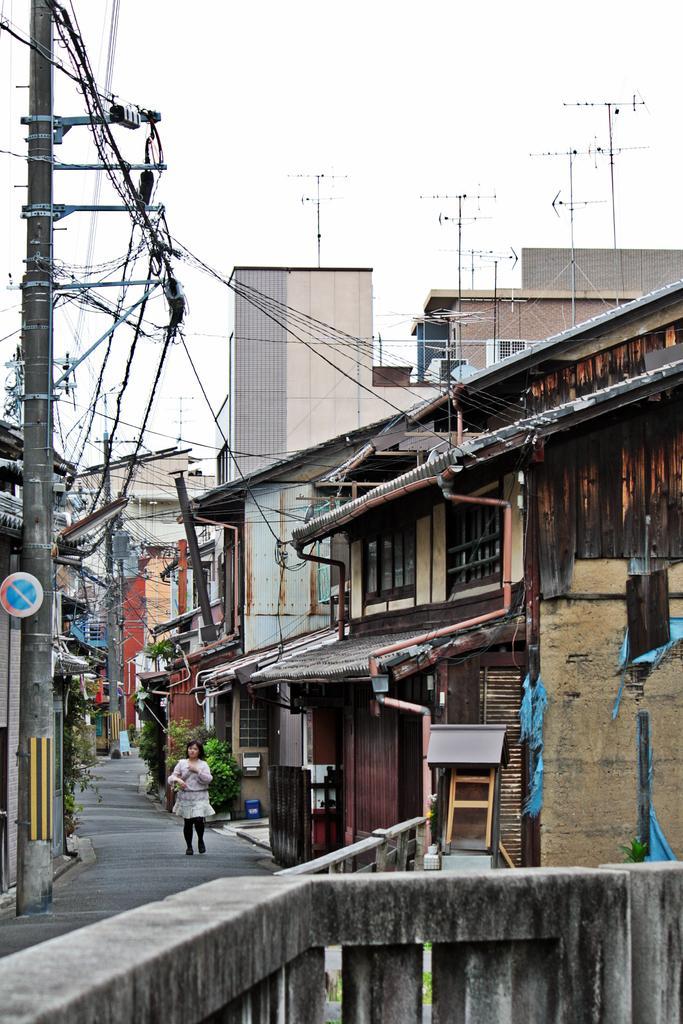Please provide a concise description of this image. In the center of the image there is a road. There is a girl. At the right side of the image there are houses. There is a electric pole and wires. At the top of the image there is sky. At the bottom of the image there is a cement railing. 